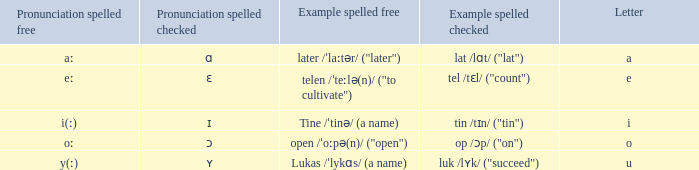What is Pronunciation Spelled Free, when Pronunciation Spelled Checked is "ɑ"? Aː. 